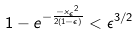Convert formula to latex. <formula><loc_0><loc_0><loc_500><loc_500>1 - e ^ { - \frac { - { x _ { \epsilon } } ^ { 2 } } { 2 ( 1 - \epsilon ) } } < \epsilon ^ { 3 / 2 }</formula> 